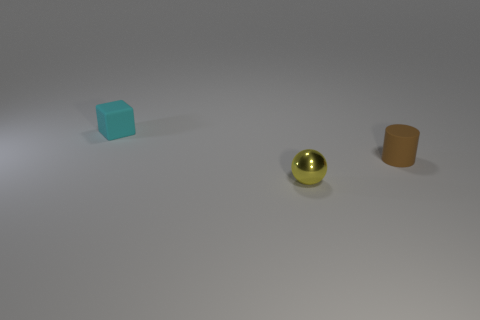What can you infer about the lighting and atmosphere based on the image? The lighting in the image appears to be soft and diffused, possibly indicating an indoor setting with a single overhead light source. This is deduced from the gentle shadows cast directly underneath each object. There's no evidence of strong directional lighting or harsh shadows. The atmosphere seems calm and controlled, with no background objects or features that would suggest a particular setting beyond a neutral, non-descript space. 